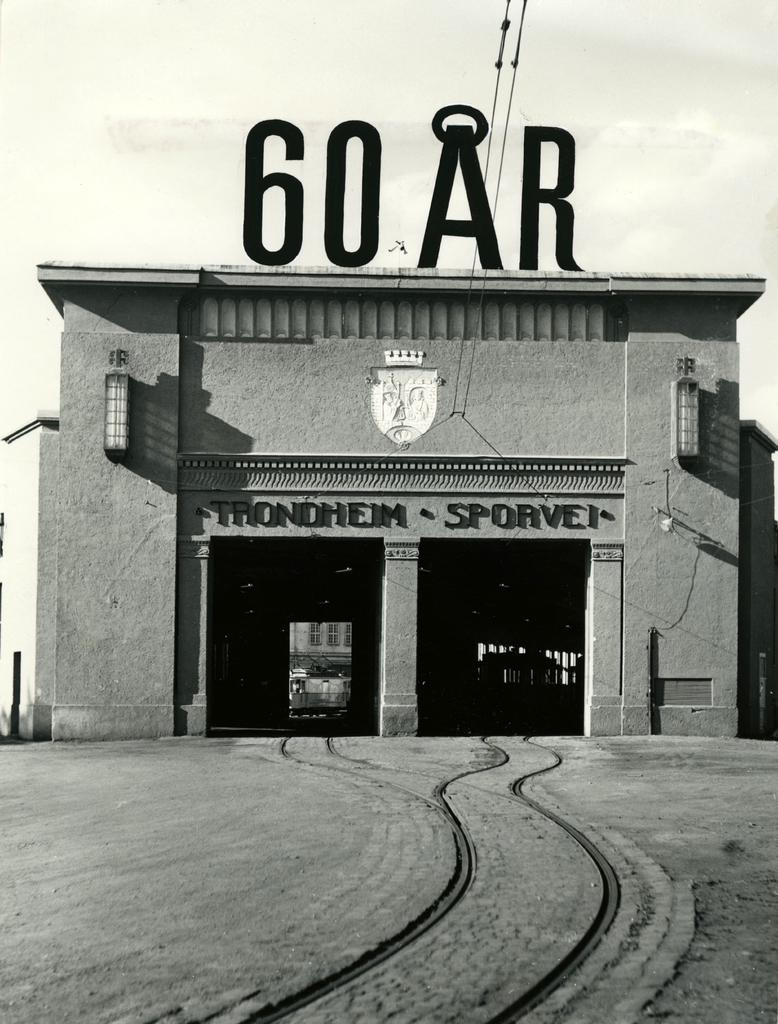What can be seen on the ground in the image? There are tracks in the image. What type of structure is present in the image? There is a building in the image. What can be seen illuminating the area in the image? There are lights in the image. What is present above the tracks in the image? There are wires in the image. What is written in the image? There is writing in the image. What color scheme is used in the image? The image is black and white in color. What type of orange is being peeled in the image? There is no orange present in the image; it is a black and white image featuring tracks, a building, lights, wires, writing, and no color. What is the name of the person standing next to the building in the image? There is no person present in the image, only a building, tracks, lights, wires, and writing. 